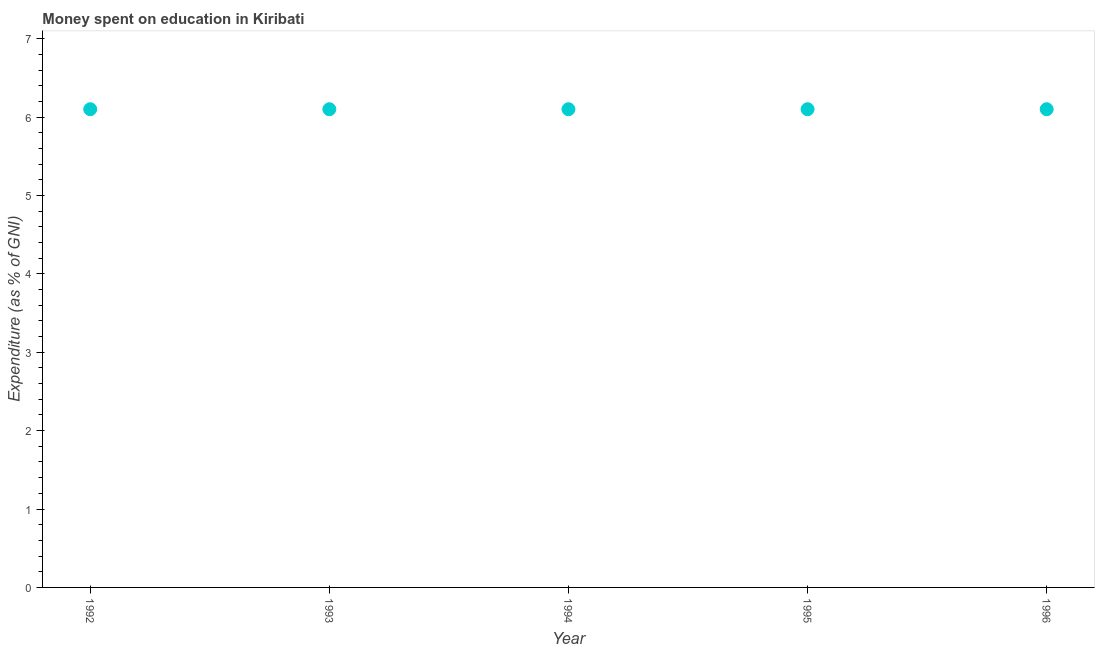Across all years, what is the maximum expenditure on education?
Offer a very short reply. 6.1. Across all years, what is the minimum expenditure on education?
Provide a succinct answer. 6.1. In which year was the expenditure on education maximum?
Provide a succinct answer. 1992. What is the sum of the expenditure on education?
Your answer should be compact. 30.5. What is the median expenditure on education?
Keep it short and to the point. 6.1. In how many years, is the expenditure on education greater than 0.8 %?
Offer a very short reply. 5. What is the difference between the highest and the second highest expenditure on education?
Keep it short and to the point. 0. Does the expenditure on education monotonically increase over the years?
Your answer should be very brief. No. Are the values on the major ticks of Y-axis written in scientific E-notation?
Provide a succinct answer. No. Does the graph contain any zero values?
Make the answer very short. No. Does the graph contain grids?
Offer a terse response. No. What is the title of the graph?
Offer a very short reply. Money spent on education in Kiribati. What is the label or title of the X-axis?
Offer a terse response. Year. What is the label or title of the Y-axis?
Keep it short and to the point. Expenditure (as % of GNI). What is the Expenditure (as % of GNI) in 1993?
Your response must be concise. 6.1. What is the Expenditure (as % of GNI) in 1994?
Provide a succinct answer. 6.1. What is the difference between the Expenditure (as % of GNI) in 1992 and 1994?
Your answer should be compact. 0. What is the difference between the Expenditure (as % of GNI) in 1992 and 1995?
Provide a short and direct response. 0. What is the difference between the Expenditure (as % of GNI) in 1992 and 1996?
Provide a succinct answer. 0. What is the difference between the Expenditure (as % of GNI) in 1993 and 1996?
Ensure brevity in your answer.  0. What is the difference between the Expenditure (as % of GNI) in 1994 and 1995?
Your response must be concise. 0. What is the difference between the Expenditure (as % of GNI) in 1995 and 1996?
Your answer should be compact. 0. What is the ratio of the Expenditure (as % of GNI) in 1992 to that in 1993?
Give a very brief answer. 1. What is the ratio of the Expenditure (as % of GNI) in 1992 to that in 1994?
Make the answer very short. 1. What is the ratio of the Expenditure (as % of GNI) in 1992 to that in 1995?
Your answer should be very brief. 1. What is the ratio of the Expenditure (as % of GNI) in 1993 to that in 1995?
Keep it short and to the point. 1. What is the ratio of the Expenditure (as % of GNI) in 1993 to that in 1996?
Your answer should be compact. 1. What is the ratio of the Expenditure (as % of GNI) in 1994 to that in 1995?
Provide a succinct answer. 1. 